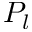Convert formula to latex. <formula><loc_0><loc_0><loc_500><loc_500>P _ { l }</formula> 